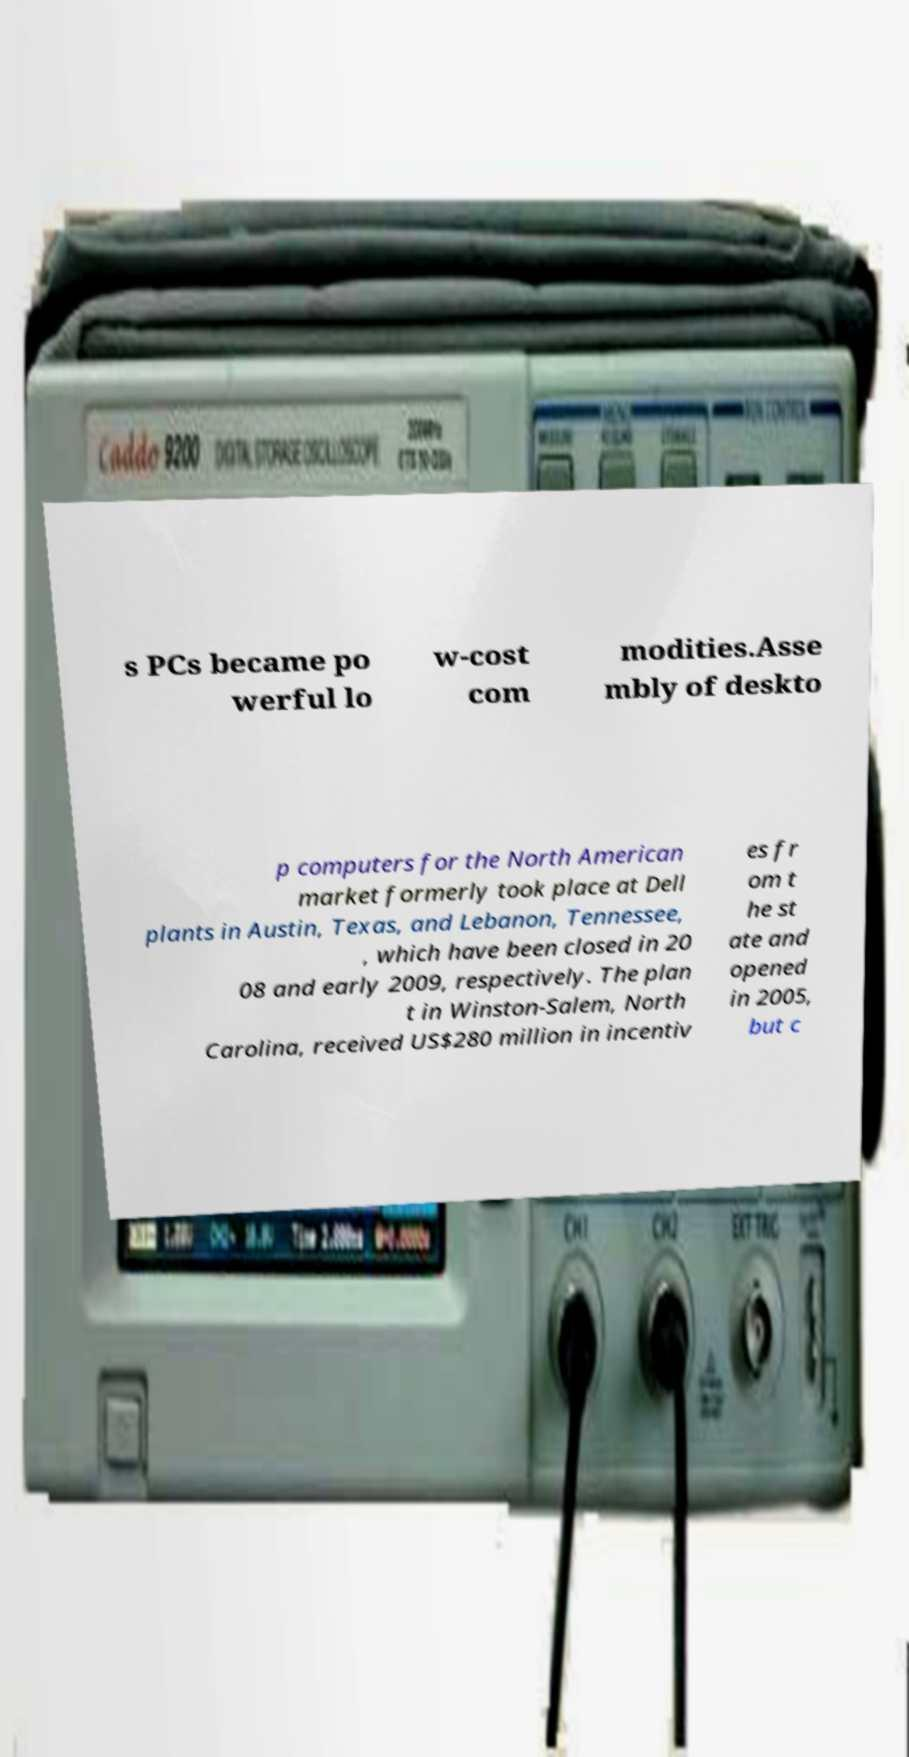For documentation purposes, I need the text within this image transcribed. Could you provide that? s PCs became po werful lo w-cost com modities.Asse mbly of deskto p computers for the North American market formerly took place at Dell plants in Austin, Texas, and Lebanon, Tennessee, , which have been closed in 20 08 and early 2009, respectively. The plan t in Winston-Salem, North Carolina, received US$280 million in incentiv es fr om t he st ate and opened in 2005, but c 